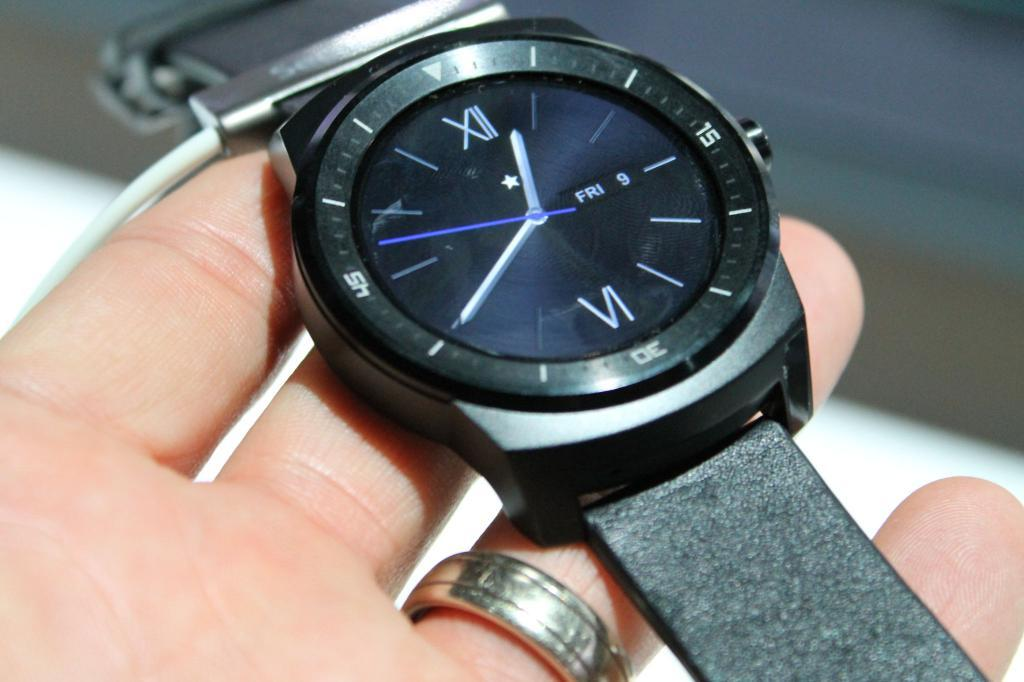Provide a one-sentence caption for the provided image. Person holding a black wristwatch which says FRI 9 on it.,. 